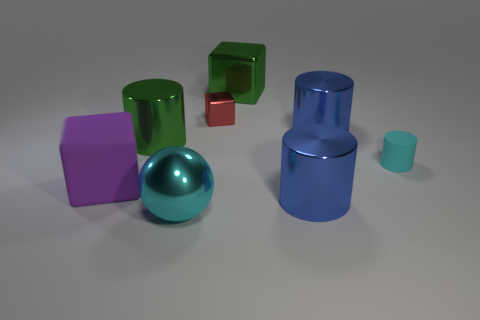Subtract all large cubes. How many cubes are left? 1 Subtract all purple cubes. How many cubes are left? 2 Add 1 big green metallic cylinders. How many objects exist? 9 Subtract 4 cylinders. How many cylinders are left? 0 Subtract all spheres. How many objects are left? 7 Subtract all yellow spheres. How many blue cylinders are left? 2 Subtract 0 yellow balls. How many objects are left? 8 Subtract all yellow cylinders. Subtract all yellow cubes. How many cylinders are left? 4 Subtract all big purple blocks. Subtract all small red objects. How many objects are left? 6 Add 8 big green cylinders. How many big green cylinders are left? 9 